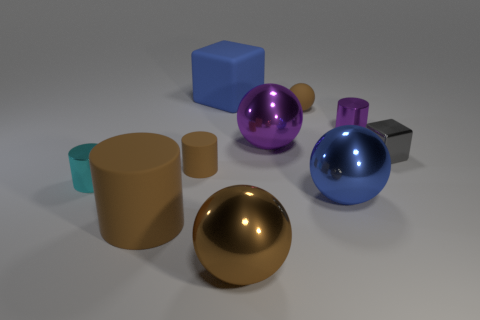There is a gray thing that is the same material as the large blue sphere; what is its shape?
Offer a very short reply. Cube. How many big things are gray metallic blocks or metal things?
Your response must be concise. 3. What number of other objects are the same color as the tiny block?
Your answer should be very brief. 0. What number of large blue balls are behind the blue object behind the small cylinder behind the tiny gray thing?
Provide a succinct answer. 0. Do the brown rubber thing that is in front of the blue metallic thing and the blue metal thing have the same size?
Ensure brevity in your answer.  Yes. Are there fewer tiny gray objects that are to the left of the tiny brown rubber cylinder than tiny cyan objects that are to the right of the purple metal ball?
Your answer should be very brief. No. Is the color of the shiny cube the same as the tiny matte cylinder?
Your answer should be compact. No. Is the number of cubes that are behind the tiny purple cylinder less than the number of tiny blocks?
Make the answer very short. No. There is a large sphere that is the same color as the big cylinder; what material is it?
Your answer should be very brief. Metal. Are the cyan cylinder and the big blue ball made of the same material?
Keep it short and to the point. Yes. 